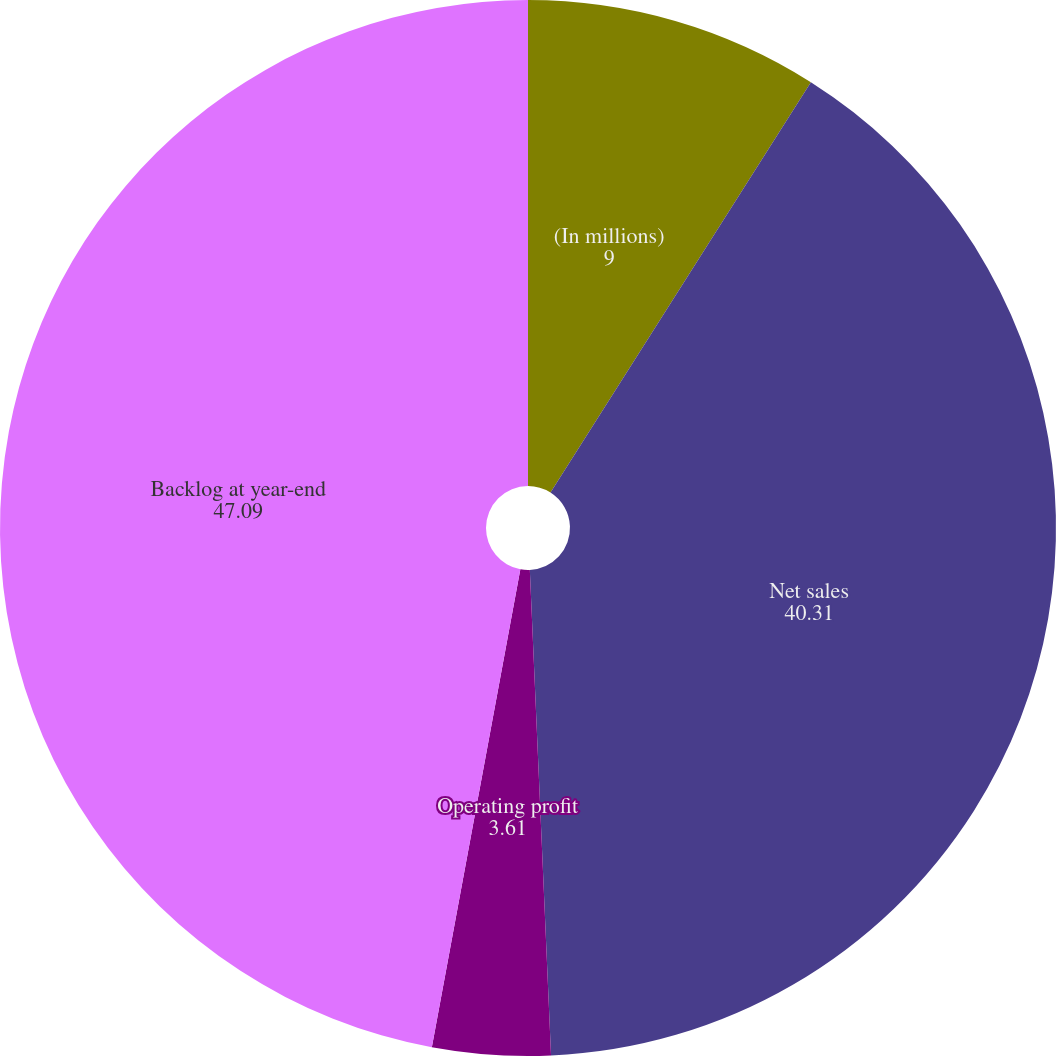Convert chart to OTSL. <chart><loc_0><loc_0><loc_500><loc_500><pie_chart><fcel>(In millions)<fcel>Net sales<fcel>Operating profit<fcel>Backlog at year-end<nl><fcel>9.0%<fcel>40.31%<fcel>3.61%<fcel>47.09%<nl></chart> 